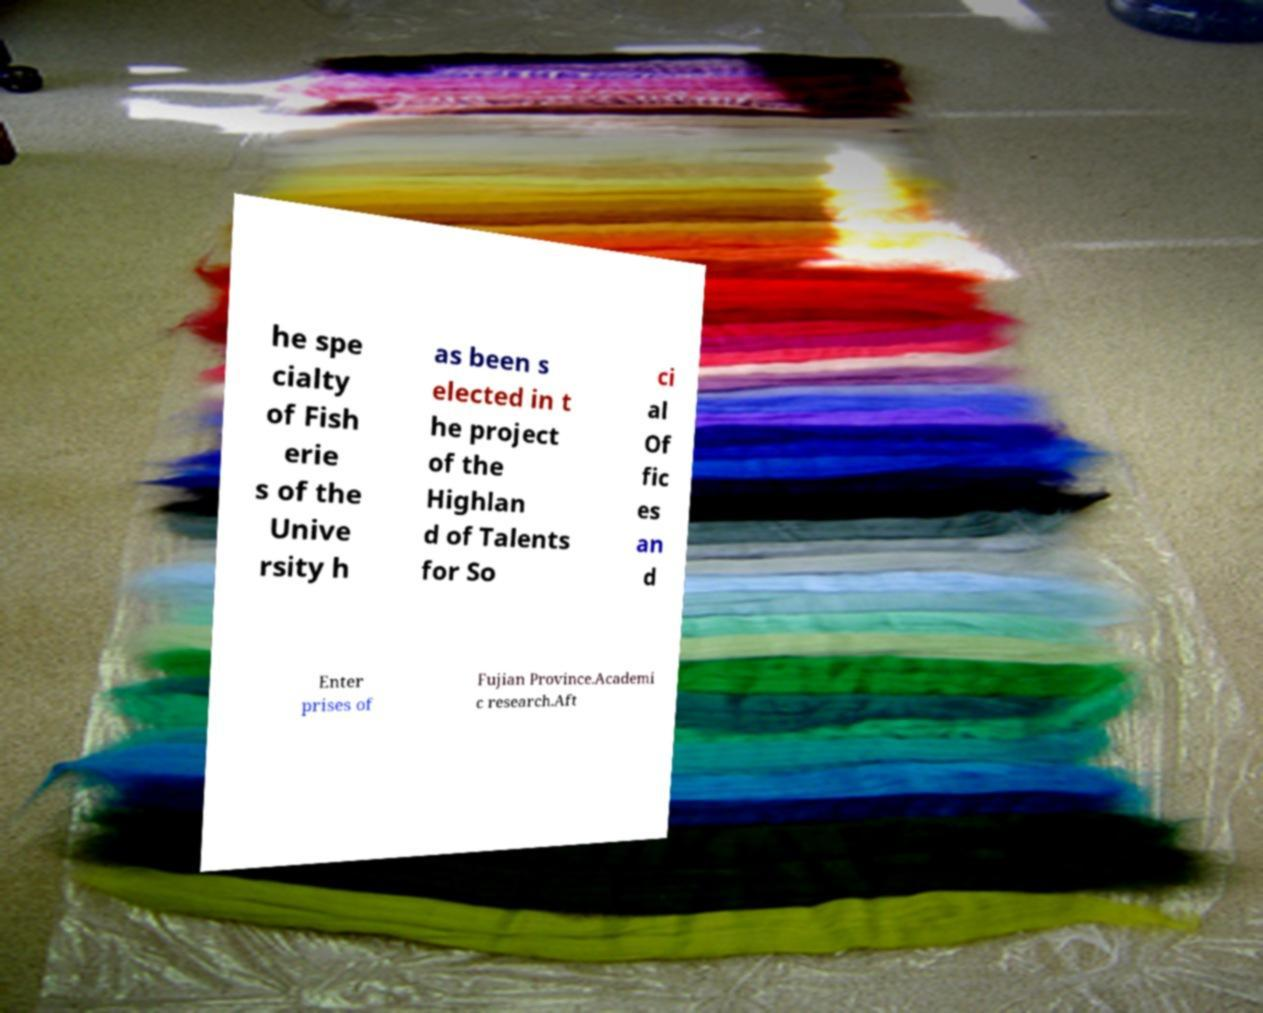I need the written content from this picture converted into text. Can you do that? he spe cialty of Fish erie s of the Unive rsity h as been s elected in t he project of the Highlan d of Talents for So ci al Of fic es an d Enter prises of Fujian Province.Academi c research.Aft 